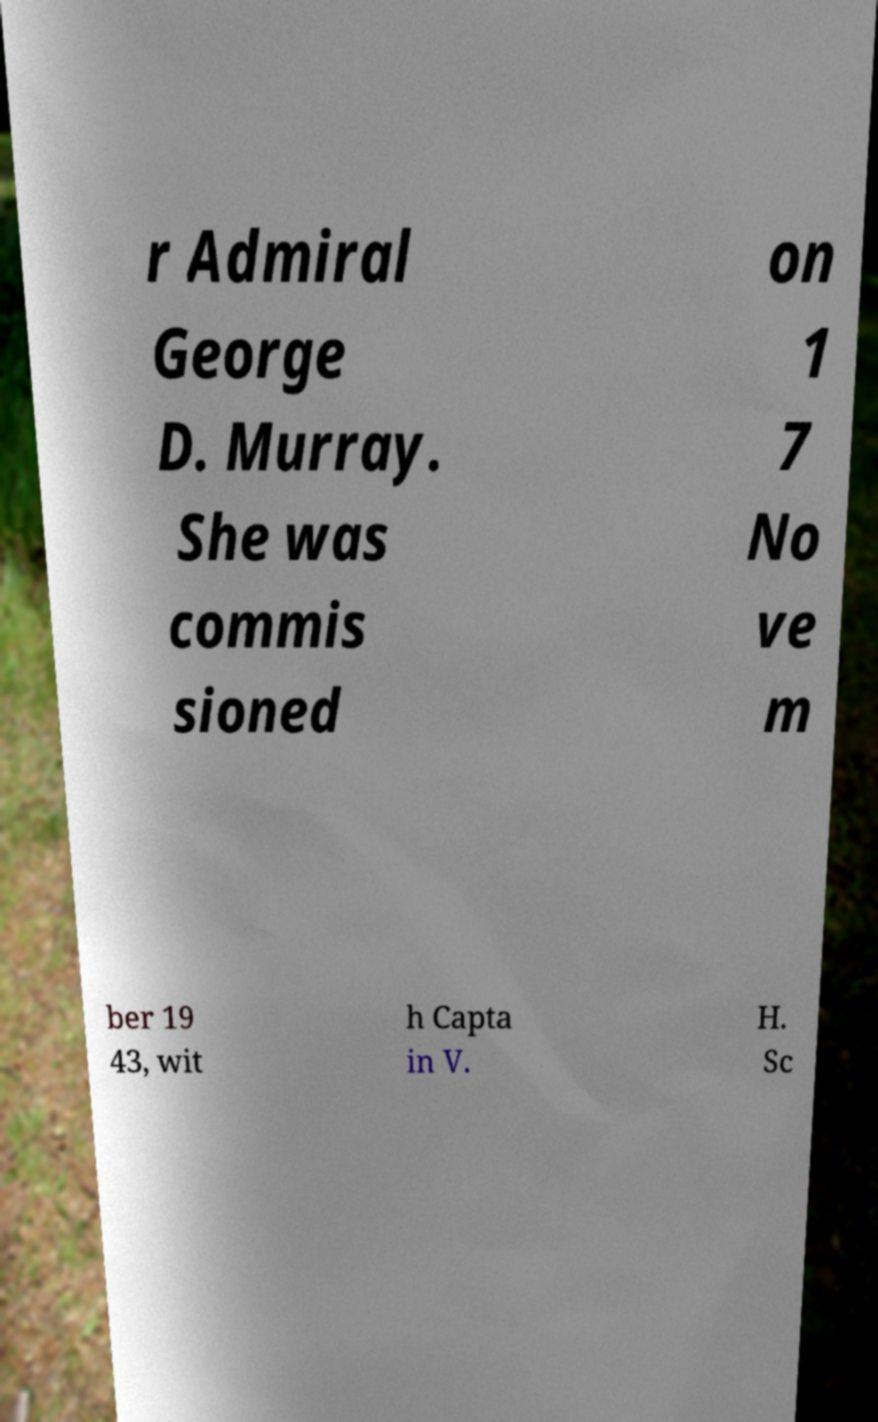There's text embedded in this image that I need extracted. Can you transcribe it verbatim? r Admiral George D. Murray. She was commis sioned on 1 7 No ve m ber 19 43, wit h Capta in V. H. Sc 